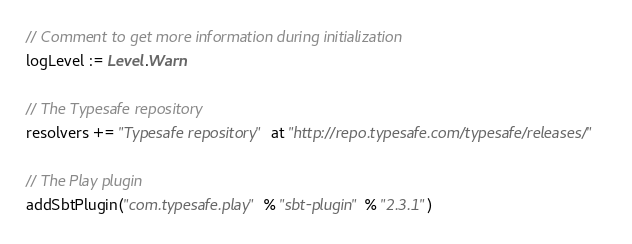<code> <loc_0><loc_0><loc_500><loc_500><_Scala_>// Comment to get more information during initialization
logLevel := Level.Warn

// The Typesafe repository
resolvers += "Typesafe repository" at "http://repo.typesafe.com/typesafe/releases/"

// The Play plugin
addSbtPlugin("com.typesafe.play" % "sbt-plugin" % "2.3.1")
</code> 